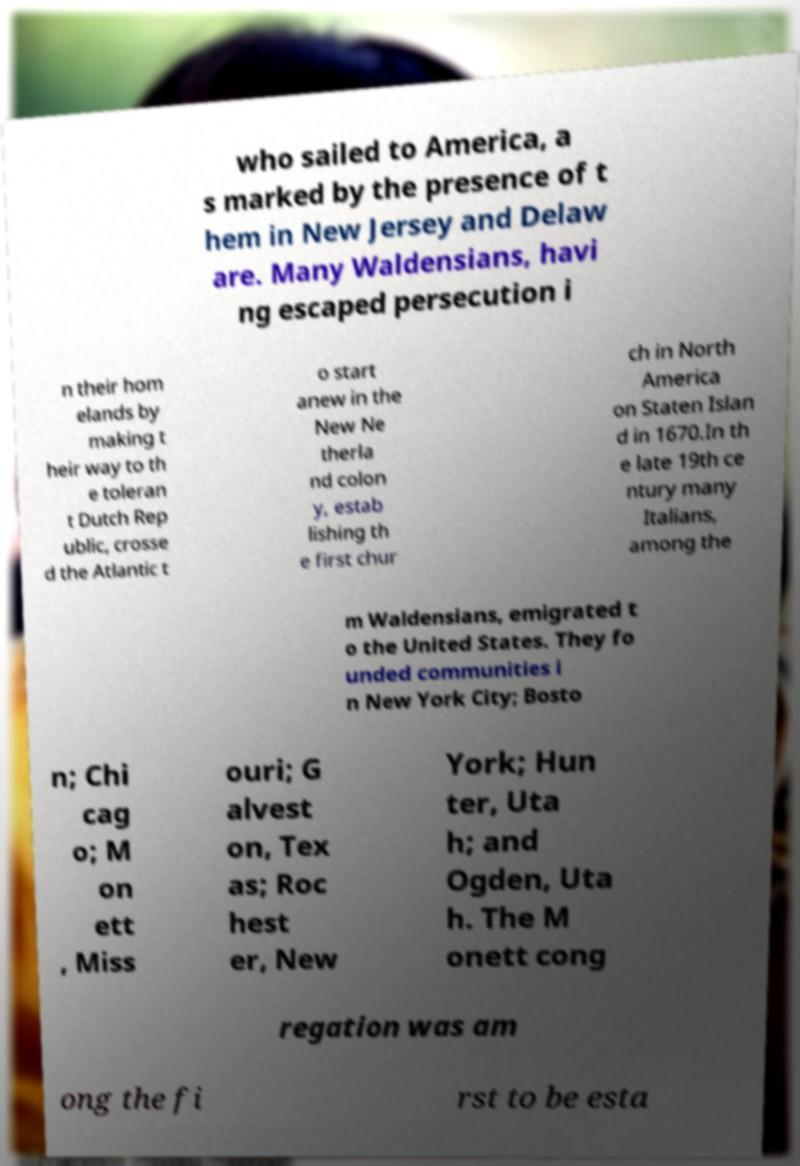There's text embedded in this image that I need extracted. Can you transcribe it verbatim? who sailed to America, a s marked by the presence of t hem in New Jersey and Delaw are. Many Waldensians, havi ng escaped persecution i n their hom elands by making t heir way to th e toleran t Dutch Rep ublic, crosse d the Atlantic t o start anew in the New Ne therla nd colon y, estab lishing th e first chur ch in North America on Staten Islan d in 1670.In th e late 19th ce ntury many Italians, among the m Waldensians, emigrated t o the United States. They fo unded communities i n New York City; Bosto n; Chi cag o; M on ett , Miss ouri; G alvest on, Tex as; Roc hest er, New York; Hun ter, Uta h; and Ogden, Uta h. The M onett cong regation was am ong the fi rst to be esta 